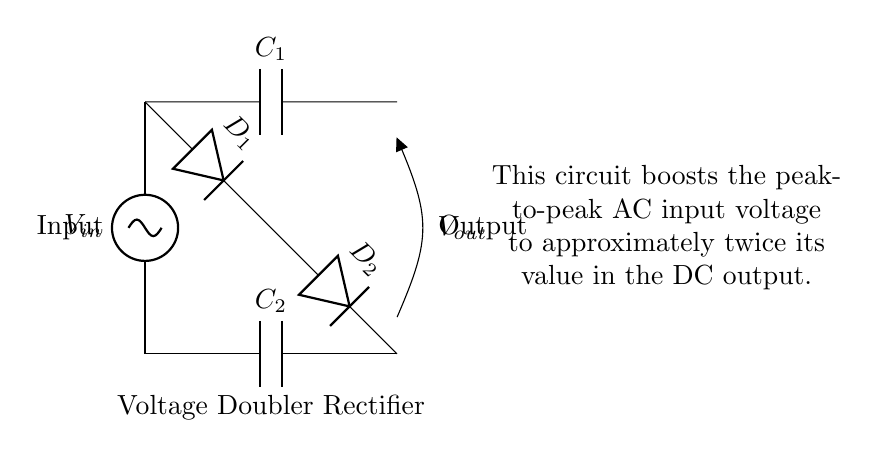What is the type of the circuit shown? The circuit is a voltage doubler rectifier circuit, which is specific for converting AC voltage into a boosted DC voltage.
Answer: Voltage doubler rectifier What components are used in this circuit? The circuit includes two capacitors (C1 and C2) and two diodes (D1 and D2), which are key elements for the voltage doubling process.
Answer: Capacitors and diodes What does C1 do in the circuit? C1 is used to charge during the positive half-cycle of the AC input, storing energy that contributes to boosting the output voltage in the next cycle.
Answer: Charges during positive half-cycle What is the function of D2 in this circuit? D2 allows current to flow from C1 to the output during the negative half-cycle of the AC input, enabling the circuit to take advantage of both halves of the AC wave for voltage doubling.
Answer: Allows current to output in negative cycle How does this circuit affect the output voltage compared to the input voltage? The voltage doubler circuit is designed to output a DC voltage that is approximately twice the peak of the AC input voltage, effectively boosting the voltage for applications like electronic testing.
Answer: Doubles the peak-to-peak AC voltage What is the purpose of the capacitors in this circuit? The capacitors in the voltage doubler rectifier circuit store and release electrical energy, facilitating the conversion of AC to a higher DC voltage by accumulating charge over the cycles.
Answer: Store and release energy What is the output voltage relative to the input voltage? The output voltage is approximately twice the peak voltage of the input, which represents the main function of the circuit to boost voltage.
Answer: Approximately twice the input voltage 